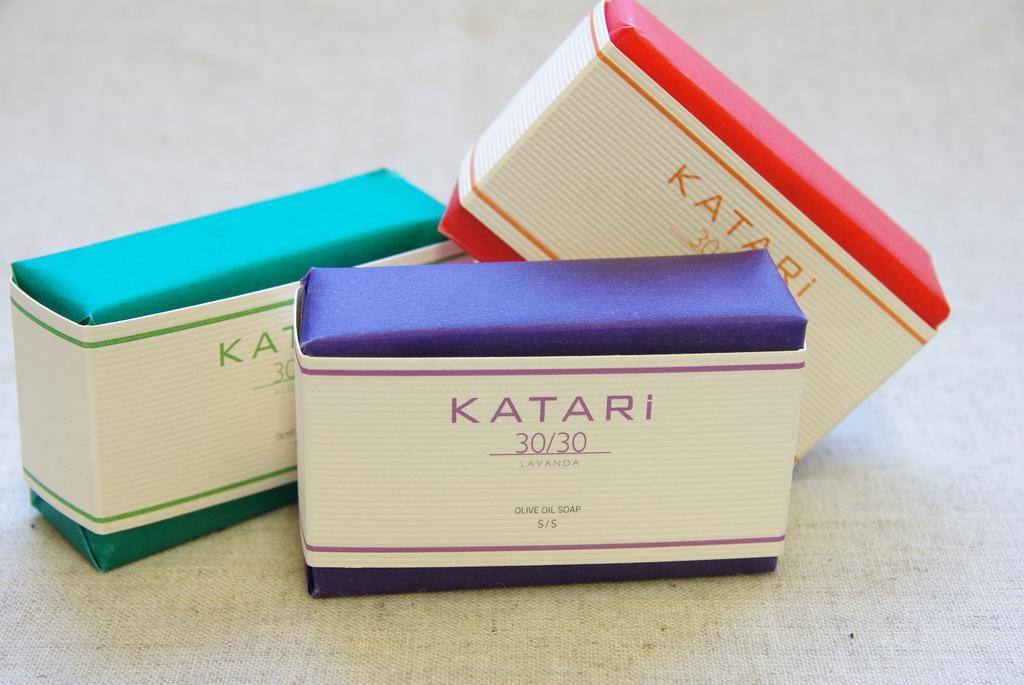<image>
Present a compact description of the photo's key features. the word Katari is on the item with blue on it 